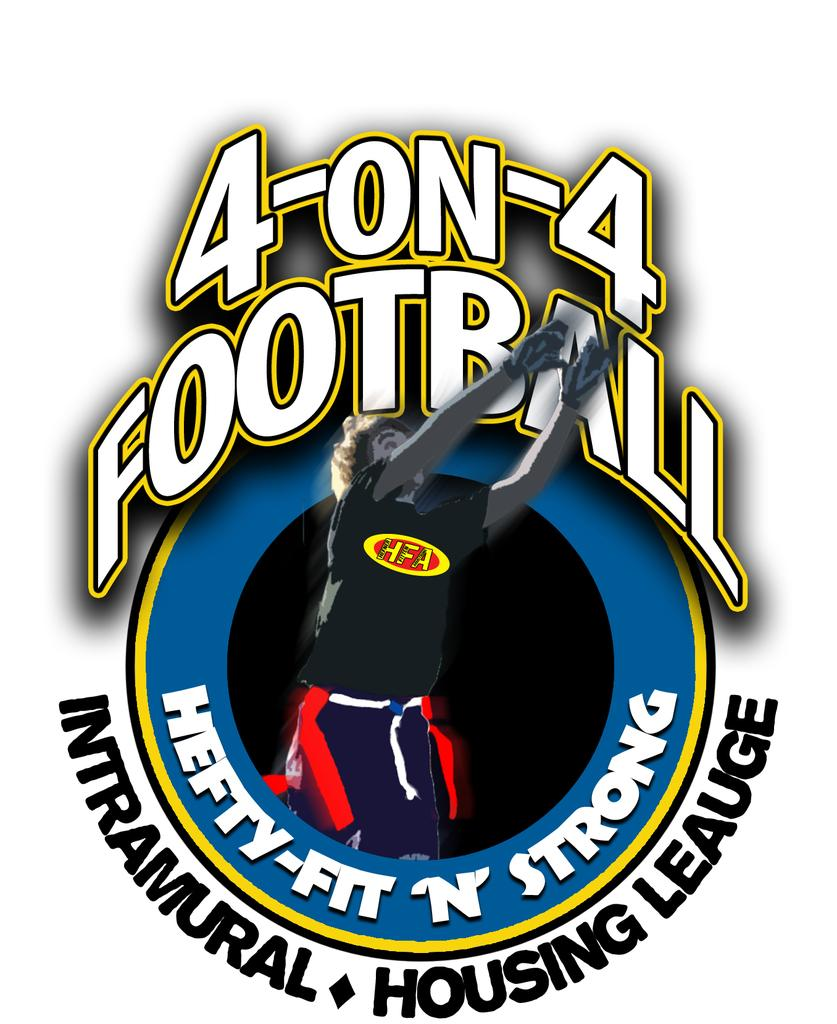Provide a one-sentence caption for the provided image. Four on Four football logo for the hefty, fit, and strong. 